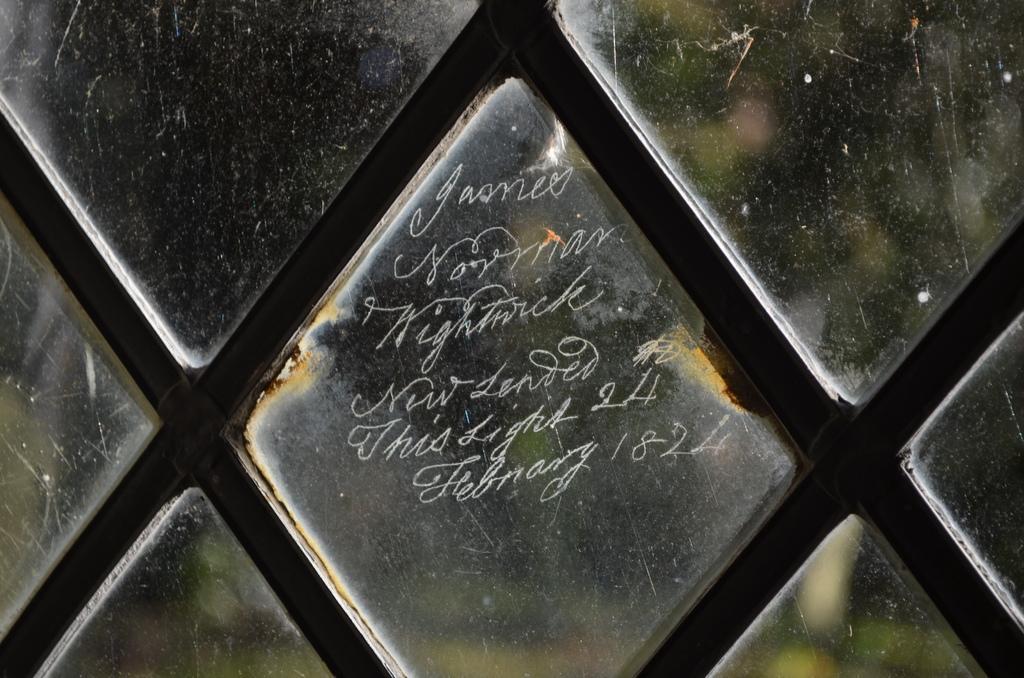In one or two sentences, can you explain what this image depicts? In this image we can see some text on the glass window. 